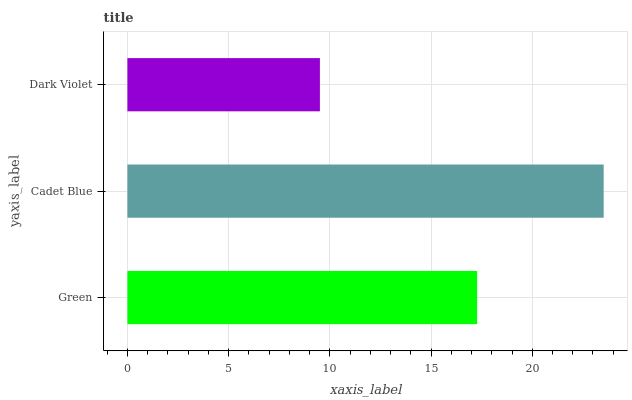Is Dark Violet the minimum?
Answer yes or no. Yes. Is Cadet Blue the maximum?
Answer yes or no. Yes. Is Cadet Blue the minimum?
Answer yes or no. No. Is Dark Violet the maximum?
Answer yes or no. No. Is Cadet Blue greater than Dark Violet?
Answer yes or no. Yes. Is Dark Violet less than Cadet Blue?
Answer yes or no. Yes. Is Dark Violet greater than Cadet Blue?
Answer yes or no. No. Is Cadet Blue less than Dark Violet?
Answer yes or no. No. Is Green the high median?
Answer yes or no. Yes. Is Green the low median?
Answer yes or no. Yes. Is Cadet Blue the high median?
Answer yes or no. No. Is Dark Violet the low median?
Answer yes or no. No. 